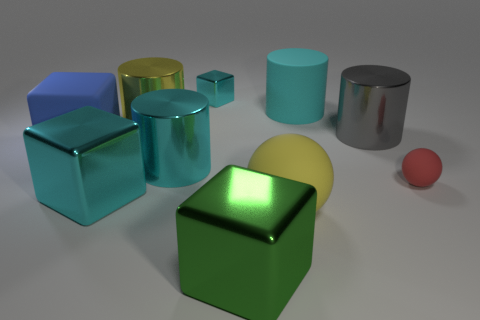Subtract 1 cubes. How many cubes are left? 3 Subtract all yellow cylinders. Subtract all brown spheres. How many cylinders are left? 3 Subtract all balls. How many objects are left? 8 Add 2 large blue cubes. How many large blue cubes exist? 3 Subtract 0 blue cylinders. How many objects are left? 10 Subtract all large gray metal things. Subtract all balls. How many objects are left? 7 Add 5 big gray metal cylinders. How many big gray metal cylinders are left? 6 